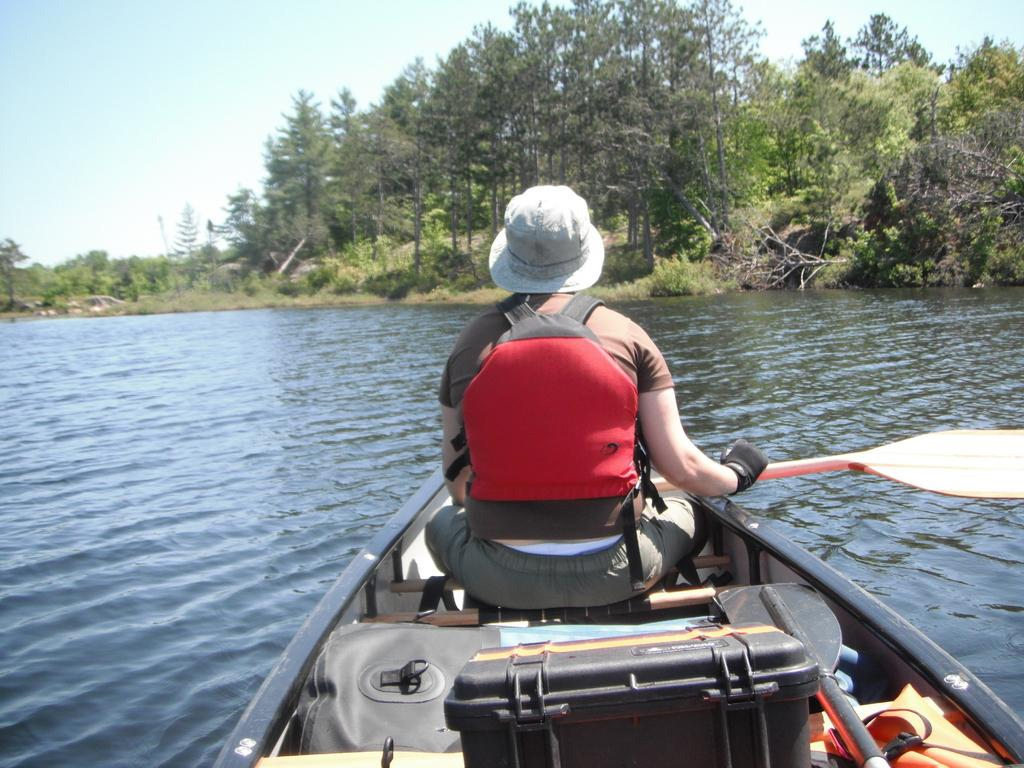What is the person in the image doing? The person is sailing on a boat in the image. Where is the boat located? The boat is on a river. What is the person using to propel the boat? The person is holding an oar. What type of vegetation can be seen in the image? There are plants and trees in the image. What is visible in the background of the image? The sky is visible in the image. What type of pie is being served on the boat in the image? There is no pie present in the image; it features a person sailing on a boat with an oar. 